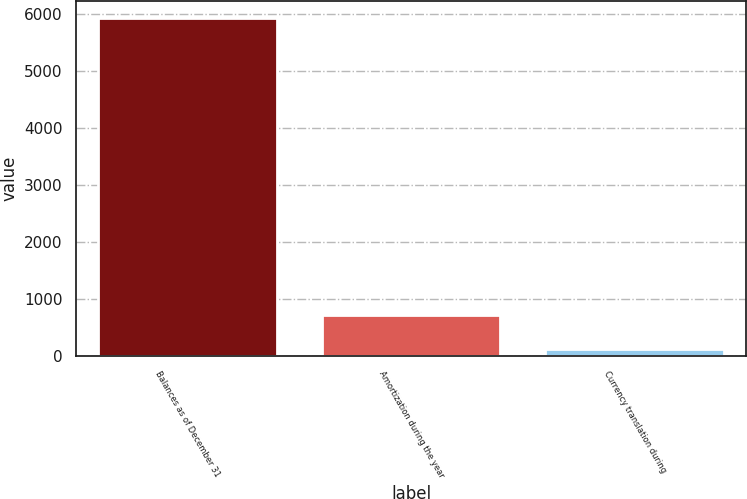Convert chart. <chart><loc_0><loc_0><loc_500><loc_500><bar_chart><fcel>Balances as of December 31<fcel>Amortization during the year<fcel>Currency translation during<nl><fcel>5926.7<fcel>722.7<fcel>127<nl></chart> 